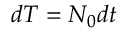Convert formula to latex. <formula><loc_0><loc_0><loc_500><loc_500>d T = N _ { 0 } d t</formula> 